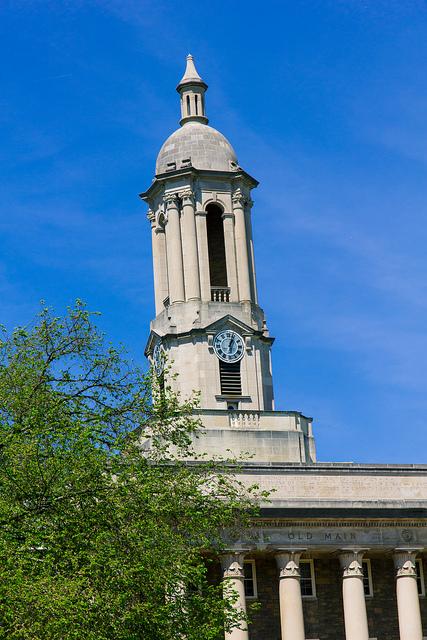Is it legal to park next to this object?
Answer briefly. Yes. Is the tree or tower taller?
Concise answer only. Tower. How many clocks are on this tower?
Keep it brief. 1. What time is it?
Quick response, please. 1:05. What religious symbol is on top of the building?
Give a very brief answer. None. What color are the arches around the windows?
Answer briefly. White. What time of day is it?
Give a very brief answer. Afternoon. 